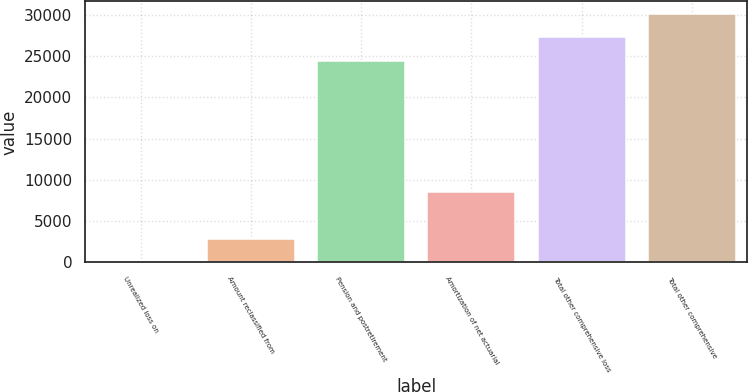<chart> <loc_0><loc_0><loc_500><loc_500><bar_chart><fcel>Unrealized loss on<fcel>Amount reclassified from<fcel>Pension and postretirement<fcel>Amortization of net actuarial<fcel>Total other comprehensive loss<fcel>Total other comprehensive<nl><fcel>22<fcel>2852<fcel>24459<fcel>8512<fcel>27289<fcel>30119<nl></chart> 